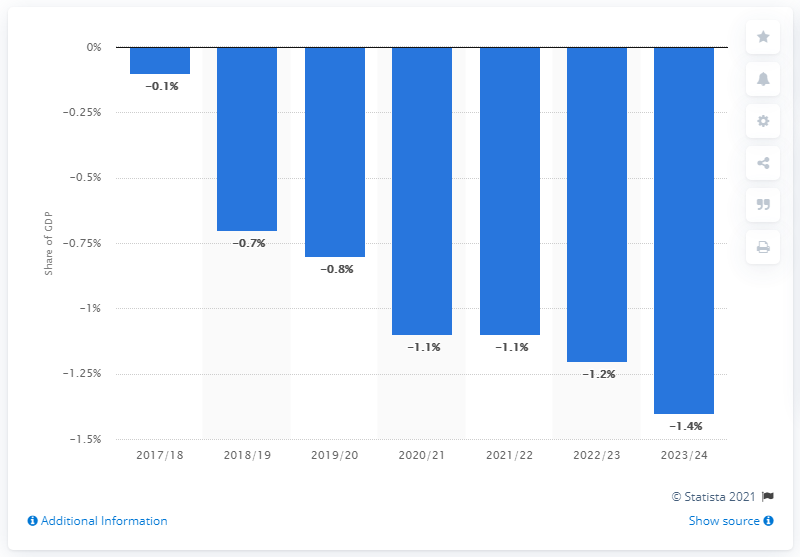What year was the UK's current budget deficit? According to the provided image which shows data from Statista 2021, the UK's current budget deficit is reflected in the fiscal year 2023/24 as approximately -1.4% of GDP. This is the most recent year indicated on the chart and represents an estimate or forecast for that period. 